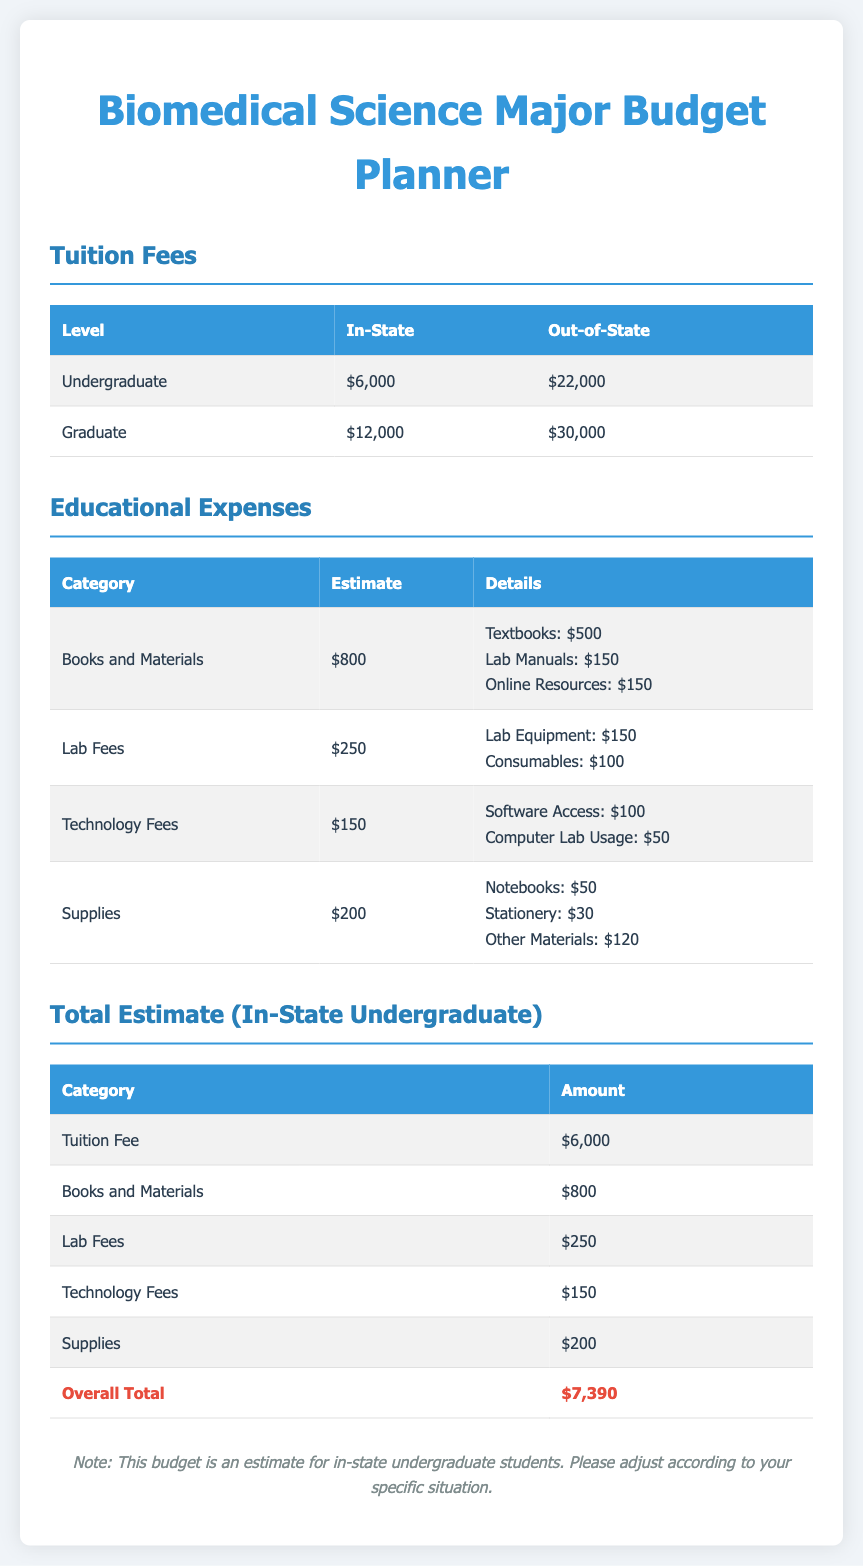What is the tuition fee for in-state undergraduate students? The tuition fee for in-state undergraduate students is listed in the document.
Answer: $6,000 What are the total educational expenses for books and materials? The document specifies the estimates for books and materials separately, which total to $800.
Answer: $800 What is the total estimate for an in-state undergraduate including all expenses? The overall total is presented in the document which combines tuition fees and other expenses.
Answer: $7,390 How much are lab fees estimated at? The lab fees are broken down in the educational expenses section of the document.
Answer: $250 What is the cost of textbooks included in the educational expenses? The document details the costs for textbooks within the books and materials.
Answer: $500 Which category has the highest estimated expense among educational expenses? By evaluating the estimates presented in the document, we can find the category with the highest expense.
Answer: Books and Materials What is the estimate for technology fees? The document lists technology fees under educational expenses with an estimate.
Answer: $150 What additional items are included under supplies? The supplies section in the educational expenses details the additional items included.
Answer: Notebooks, Stationery, Other Materials How much is estimated for lab equipment specifically within lab fees? The document specifies the amount allocated for lab equipment as part of the lab fees.
Answer: $150 